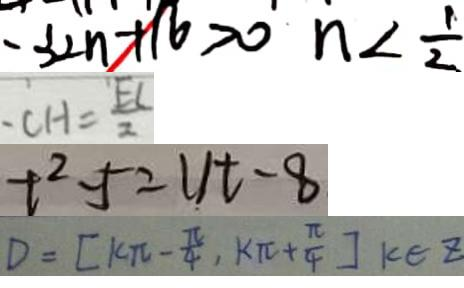<formula> <loc_0><loc_0><loc_500><loc_500>- 3 2 n + 1 6 > 0 n < \frac { 1 } { 2 } 
 - C H = \frac { E L } { 2 } 
 t ^ { 2 } - 5 = 1 1 t - 8 
 D = [ k \pi - \frac { \pi } { 4 } , k \pi + \frac { \pi } { 4 } ] k \in z</formula> 